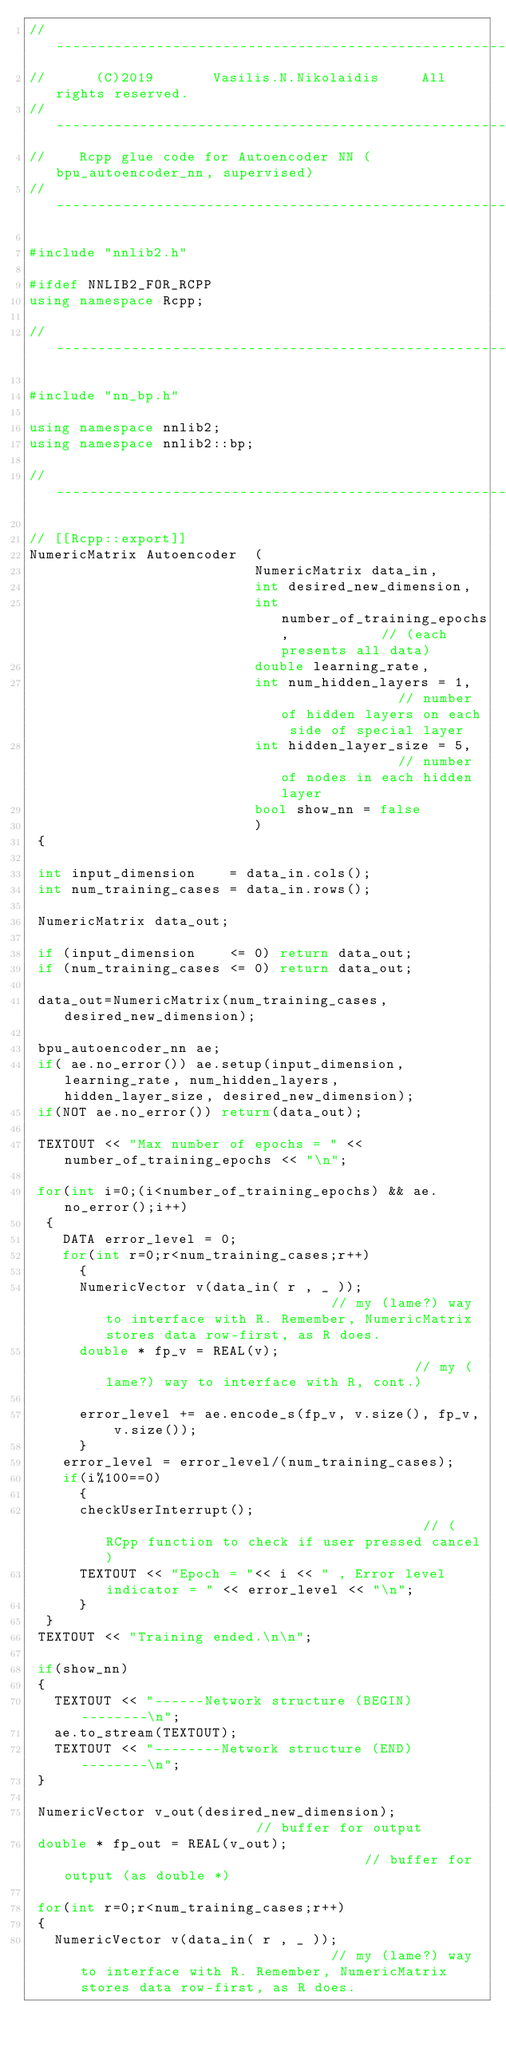<code> <loc_0><loc_0><loc_500><loc_500><_C++_>//		----------------------------------------------------------
//		(C)2019       Vasilis.N.Nikolaidis     All rights reserved.
//		-----------------------------------------------------------
//    Rcpp glue code for Autoencoder NN (bpu_autoencoder_nn, supervised)
//		-----------------------------------------------------------

#include "nnlib2.h"

#ifdef NNLIB2_FOR_RCPP
using namespace Rcpp;

//--------------------------------------------------------------------------------

#include "nn_bp.h"

using namespace nnlib2;
using namespace nnlib2::bp;

//--------------------------------------------------------------------------------

// [[Rcpp::export]]
NumericMatrix Autoencoder  (
                           NumericMatrix data_in,
                           int desired_new_dimension,
                           int number_of_training_epochs,           // (each presents all data)
                           double learning_rate,
                           int num_hidden_layers = 1,               // number of hidden layers on each side of special layer
                           int hidden_layer_size = 5,               // number of nodes in each hidden layer
                           bool show_nn = false
                           )
 {

 int input_dimension    = data_in.cols();
 int num_training_cases = data_in.rows();

 NumericMatrix data_out;

 if (input_dimension    <= 0) return data_out;
 if (num_training_cases <= 0) return data_out;

 data_out=NumericMatrix(num_training_cases,desired_new_dimension);

 bpu_autoencoder_nn ae;
 if( ae.no_error()) ae.setup(input_dimension, learning_rate, num_hidden_layers, hidden_layer_size, desired_new_dimension);
 if(NOT ae.no_error()) return(data_out);

 TEXTOUT << "Max number of epochs = " << number_of_training_epochs << "\n";

 for(int i=0;(i<number_of_training_epochs) && ae.no_error();i++)
  {
    DATA error_level = 0;
    for(int r=0;r<num_training_cases;r++)
      {
      NumericVector v(data_in( r , _ ));                            // my (lame?) way to interface with R. Remember, NumericMatrix stores data row-first, as R does.
      double * fp_v = REAL(v);                                      // my (lame?) way to interface with R, cont.)

      error_level += ae.encode_s(fp_v, v.size(), fp_v, v.size());
      }
    error_level = error_level/(num_training_cases);
    if(i%100==0)
      {
      checkUserInterrupt();                                       // (RCpp function to check if user pressed cancel)
      TEXTOUT << "Epoch = "<< i << " , Error level indicator = " << error_level << "\n";
      }
  }
 TEXTOUT << "Training ended.\n\n";

 if(show_nn)
 {
   TEXTOUT << "------Network structure (BEGIN)--------\n";
   ae.to_stream(TEXTOUT);
   TEXTOUT << "--------Network structure (END)--------\n";
 }

 NumericVector v_out(desired_new_dimension);                        // buffer for output
 double * fp_out = REAL(v_out);                                     // buffer for output (as double *)

 for(int r=0;r<num_training_cases;r++)
 {
   NumericVector v(data_in( r , _ ));                               // my (lame?) way to interface with R. Remember, NumericMatrix stores data row-first, as R does.</code> 